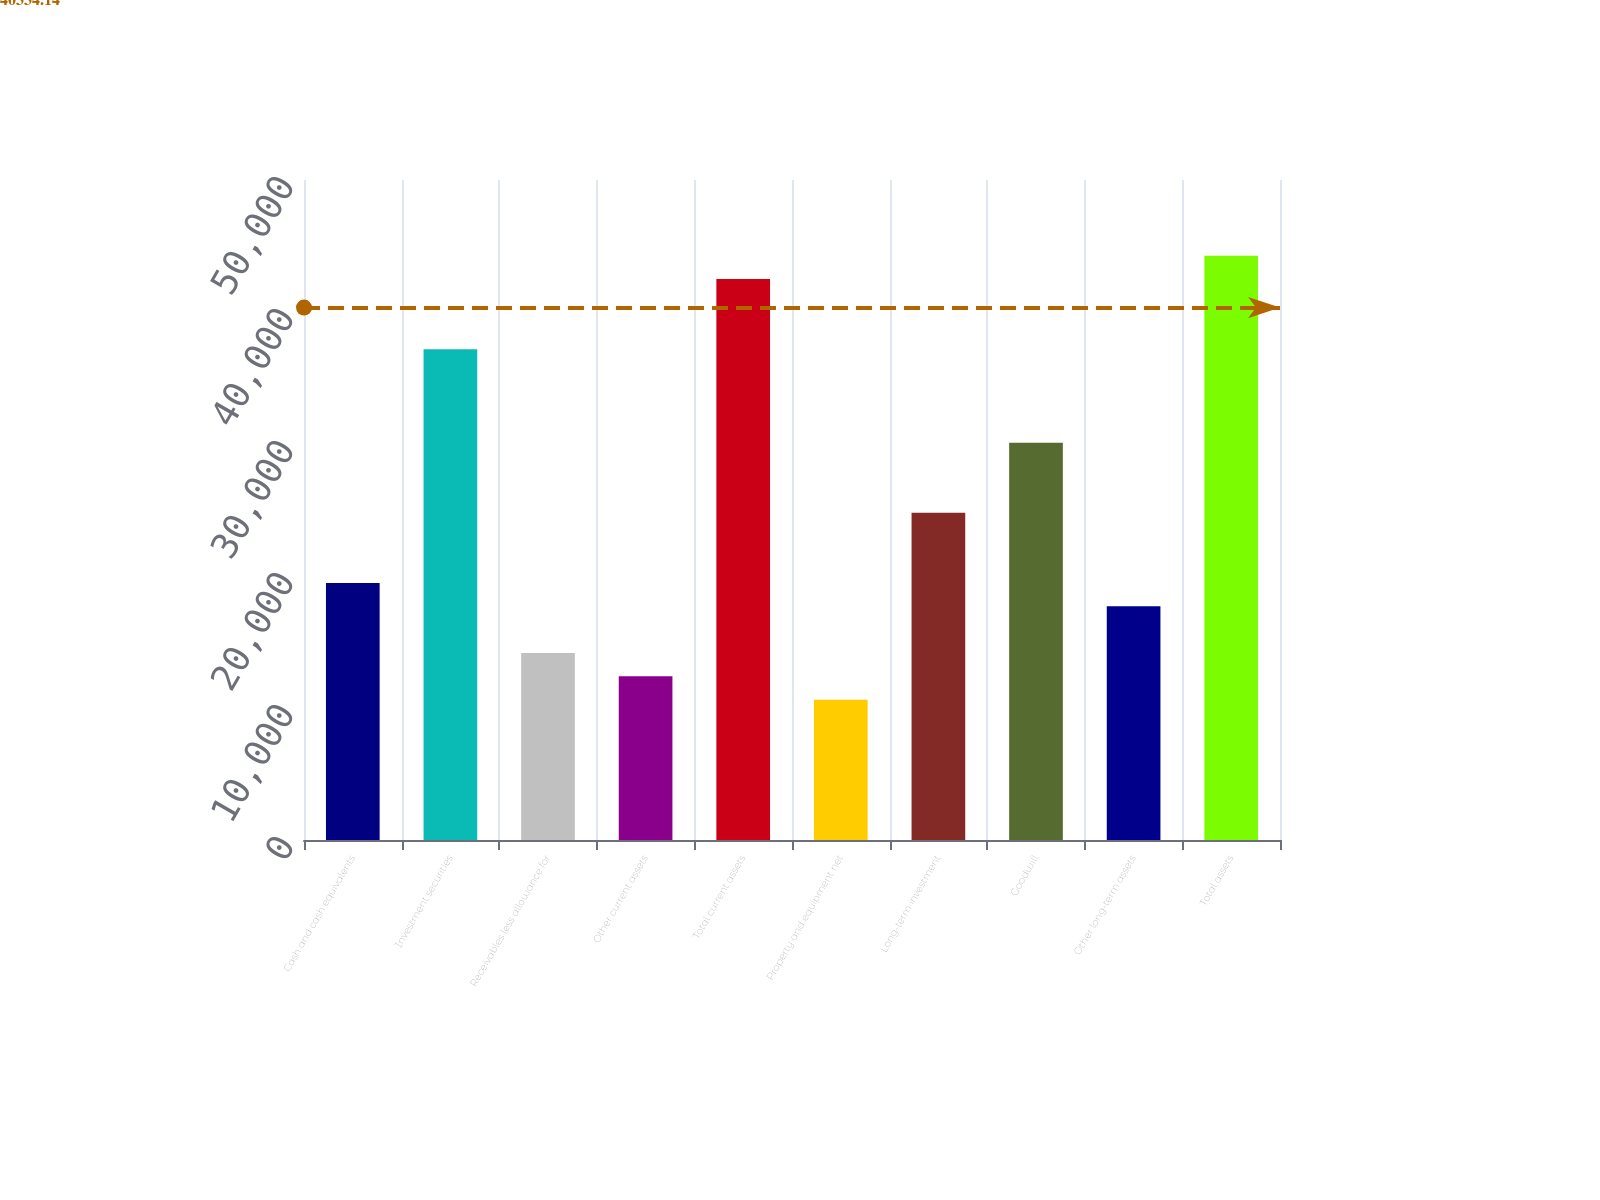Convert chart. <chart><loc_0><loc_0><loc_500><loc_500><bar_chart><fcel>Cash and cash equivalents<fcel>Investment securities<fcel>Receivables less allowance for<fcel>Other current assets<fcel>Total current assets<fcel>Property and equipment net<fcel>Long-term investment<fcel>Goodwill<fcel>Other long-term assets<fcel>Total assets<nl><fcel>19478.4<fcel>37182.2<fcel>14167.3<fcel>12396.9<fcel>42493.4<fcel>10626.5<fcel>24789.6<fcel>30100.7<fcel>17708<fcel>44263.7<nl></chart> 